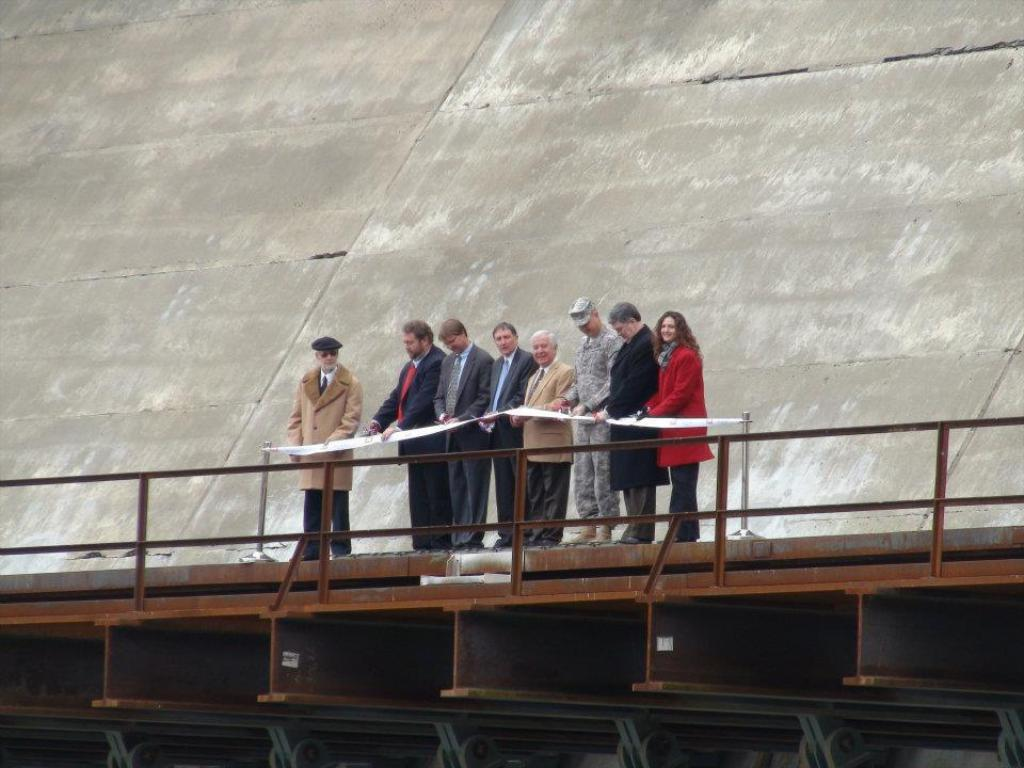What are the people in the image doing? The persons in the image are standing on the bridge. What material is used for the railing on the bridge? The bridge has metal railing. What colors can be seen in the background of the image? The background of the image is grey and white in color. Can you see any chess pieces on the bridge in the image? There are no chess pieces visible in the image; it only shows persons standing on the bridge with metal railing. What type of teeth can be seen on the dog in the image? There is no dog present in the image, so it is not possible to determine what type of teeth might be seen. 